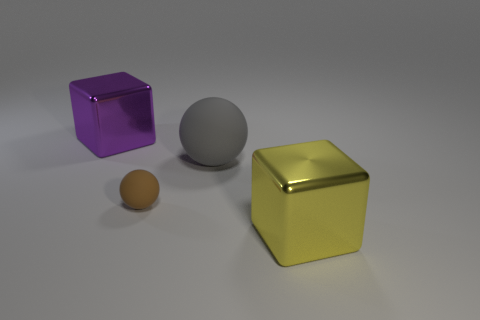The purple metallic thing is what size?
Ensure brevity in your answer.  Large. What number of other gray rubber things have the same size as the gray thing?
Make the answer very short. 0. Is the size of the cube that is to the right of the purple metal block the same as the shiny thing left of the small sphere?
Your response must be concise. Yes. What shape is the gray thing on the right side of the small brown sphere?
Provide a short and direct response. Sphere. There is a big cube on the left side of the big yellow object to the right of the gray matte object; what is it made of?
Your answer should be very brief. Metal. Are there any large cubes of the same color as the big sphere?
Your response must be concise. No. Does the brown object have the same size as the shiny cube that is in front of the purple object?
Give a very brief answer. No. There is a big block on the right side of the metal object behind the big yellow metal thing; how many tiny brown rubber balls are on the left side of it?
Your answer should be very brief. 1. There is a brown thing; what number of small brown balls are to the left of it?
Keep it short and to the point. 0. The big shiny thing that is on the left side of the shiny block in front of the brown ball is what color?
Offer a terse response. Purple. 